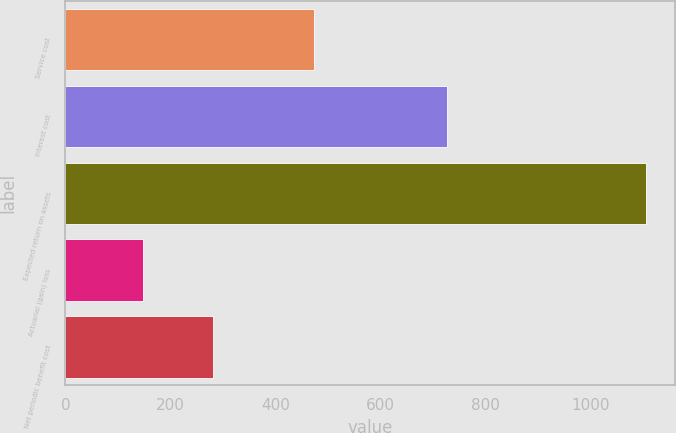Convert chart. <chart><loc_0><loc_0><loc_500><loc_500><bar_chart><fcel>Service cost<fcel>Interest cost<fcel>Expected return on assets<fcel>Actuarial (gain) loss<fcel>Net periodic benefit cost<nl><fcel>474<fcel>726<fcel>1106<fcel>148<fcel>281<nl></chart> 